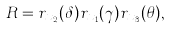Convert formula to latex. <formula><loc_0><loc_0><loc_500><loc_500>R = r _ { x _ { 2 } } ( \delta ) r _ { x _ { 1 } } ( \gamma ) r _ { x _ { 3 } } ( \theta ) ,</formula> 